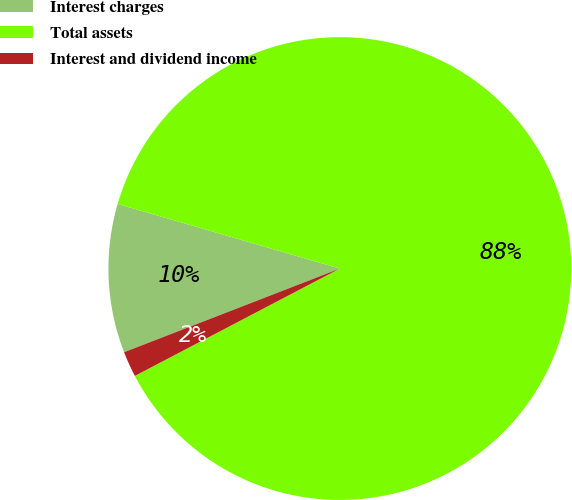Convert chart to OTSL. <chart><loc_0><loc_0><loc_500><loc_500><pie_chart><fcel>Interest charges<fcel>Total assets<fcel>Interest and dividend income<nl><fcel>10.39%<fcel>87.82%<fcel>1.79%<nl></chart> 